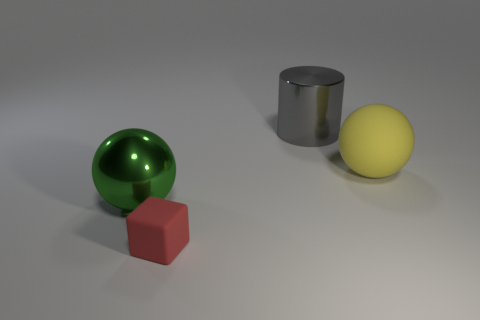There is a big green object that is the same shape as the yellow thing; what material is it?
Provide a succinct answer. Metal. Are there any large yellow shiny spheres?
Your answer should be compact. No. How big is the thing that is on the right side of the green sphere and on the left side of the gray thing?
Keep it short and to the point. Small. What is the shape of the small red object?
Your answer should be compact. Cube. There is a big yellow ball behind the red thing; are there any large green objects that are on the left side of it?
Give a very brief answer. Yes. There is a green sphere that is the same size as the metal cylinder; what is its material?
Ensure brevity in your answer.  Metal. Are there any red rubber objects that have the same size as the gray cylinder?
Keep it short and to the point. No. What is the material of the large ball that is to the left of the red matte object?
Your response must be concise. Metal. Are the thing to the right of the big gray metallic cylinder and the green sphere made of the same material?
Offer a very short reply. No. What shape is the yellow rubber object that is the same size as the green shiny sphere?
Keep it short and to the point. Sphere. 